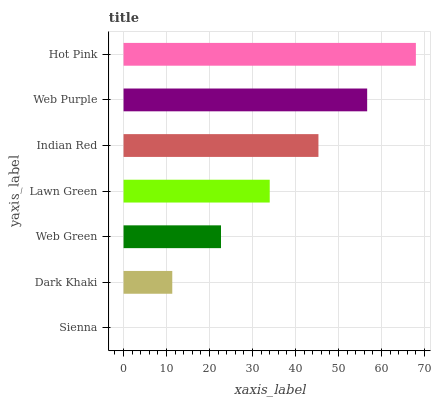Is Sienna the minimum?
Answer yes or no. Yes. Is Hot Pink the maximum?
Answer yes or no. Yes. Is Dark Khaki the minimum?
Answer yes or no. No. Is Dark Khaki the maximum?
Answer yes or no. No. Is Dark Khaki greater than Sienna?
Answer yes or no. Yes. Is Sienna less than Dark Khaki?
Answer yes or no. Yes. Is Sienna greater than Dark Khaki?
Answer yes or no. No. Is Dark Khaki less than Sienna?
Answer yes or no. No. Is Lawn Green the high median?
Answer yes or no. Yes. Is Lawn Green the low median?
Answer yes or no. Yes. Is Hot Pink the high median?
Answer yes or no. No. Is Web Green the low median?
Answer yes or no. No. 